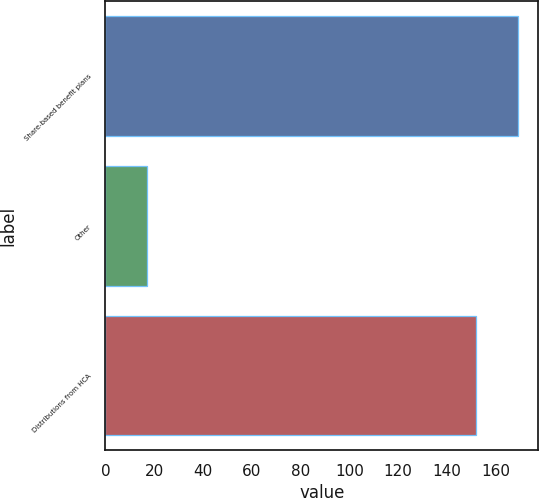<chart> <loc_0><loc_0><loc_500><loc_500><bar_chart><fcel>Share-based benefit plans<fcel>Other<fcel>Distributions from HCA<nl><fcel>169<fcel>17<fcel>152<nl></chart> 